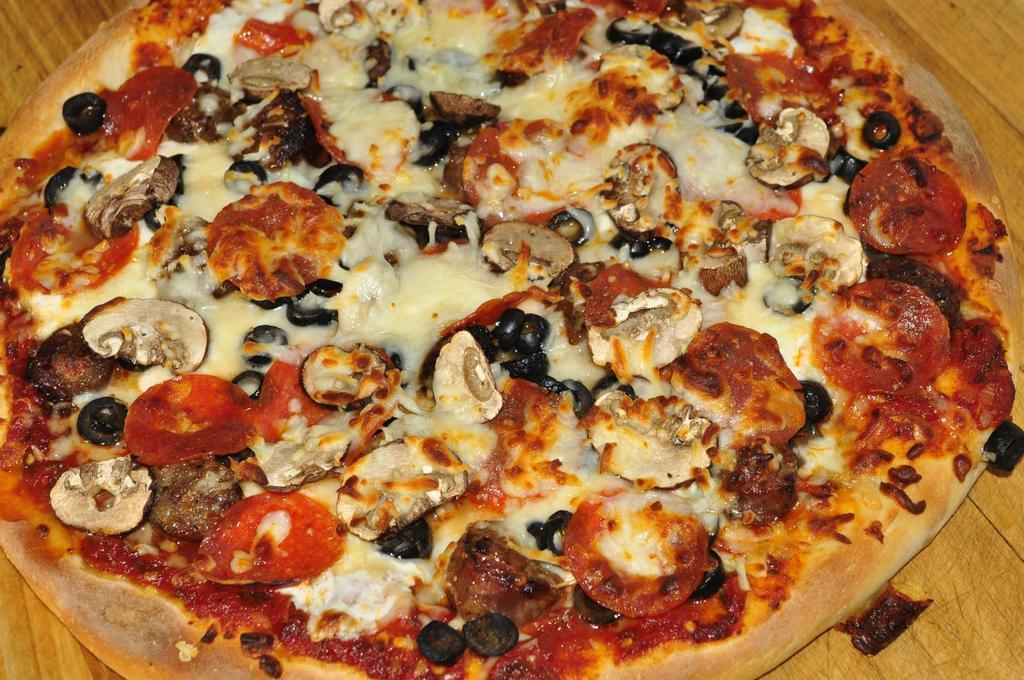What type of surface is visible in the image? There is a wooden surface in the image. What is placed on the wooden surface? There is a pizza on the wooden surface. How many deer can be seen grazing on the wooden surface in the image? There are no deer present in the image; it features a wooden surface with a pizza on it. 